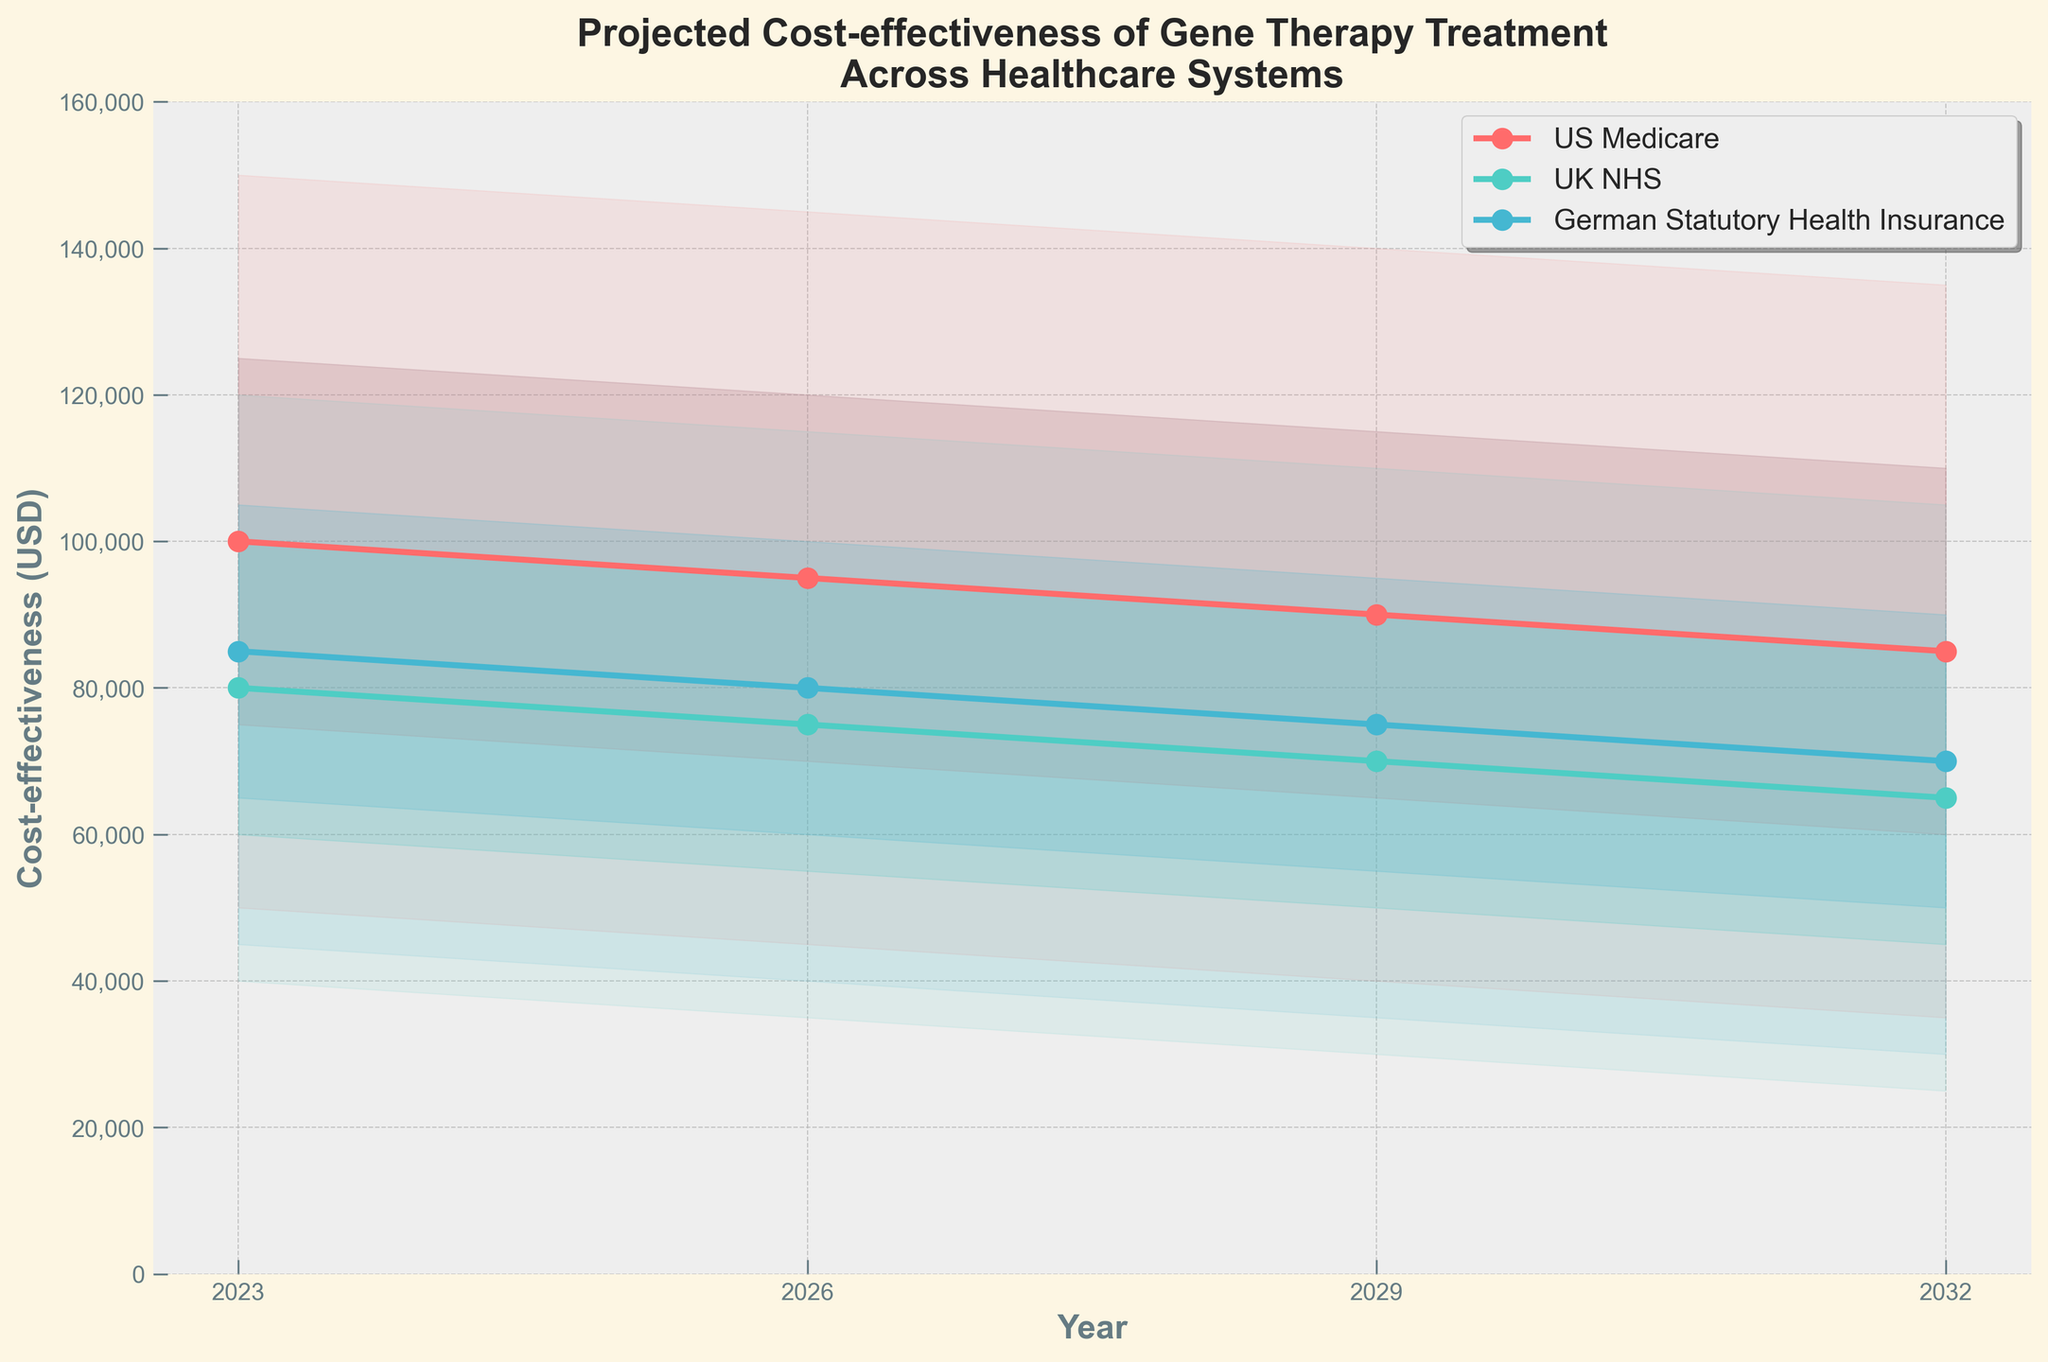What is the median projected cost-effectiveness for US Medicare in 2023? Referring to the figure, the median value is displayed for each year. For 2023, the median projected cost-effectiveness for US Medicare is the middle point of the fan chart for that year.
Answer: 100000 Which healthcare system has the lowest median projected cost-effectiveness in 2026? In 2026, compare the median values for US Medicare, UK NHS, and German Statutory Health Insurance. UK NHS shows the lowest median value.
Answer: UK NHS By how much does the upper 95% confidence interval for UK NHS in 2032 differ from the lower 95% confidence interval for US Medicare in 2026? The upper 95% confidence interval for UK NHS in 2032 is 105000, and the lower 95% confidence interval for US Medicare in 2026 is 45000. The difference is 105000 - 45000 = 60000.
Answer: 60000 Is the cost-effectiveness trend for German Statutory Health Insurance increasing or decreasing over the decade? Evaluate the median values for German Statutory Health Insurance across the years 2023, 2026, 2029, and 2032. The trend shows a decrease from 85000 in 2023 to 70000 in 2032.
Answer: Decreasing Which year shows the highest median projected cost-effectiveness for US Medicare? Compare the median values for US Medicare across the years 2023, 2026, 2029, and 2032. The highest median value is in 2023.
Answer: 2023 How does the median projected cost-effectiveness for UK NHS change from 2023 to 2029? Look at the median values for UK NHS in 2023 and 2029. The median decreases from 80000 in 2023 to 70000 in 2029.
Answer: Decreases Which healthcare system has the narrowest 80% confidence interval in 2029? The width of the 80% confidence interval is the difference between the upper and lower limits of the interval. For 2029, compare the intervals for US Medicare (50000), UK NHS (40000), and German Statutory Health Insurance (40000). UK NHS has the narrowest interval.
Answer: UK NHS Is there any year when the lower 95% confidence interval for any healthcare system exceeds 40000? Check the lower 95% confidence interval for each healthcare system across all years. In 2023, all systems have lower 95% confidence interval above 40000.
Answer: Yes What is the range of the projected cost-effectiveness for German Statutory Health Insurance for the year 2026 according to the 95% confidence interval? The range is the difference between the upper and lower 95% confidence intervals. For 2026, it’s 120000 - 40000 = 80000.
Answer: 80000 